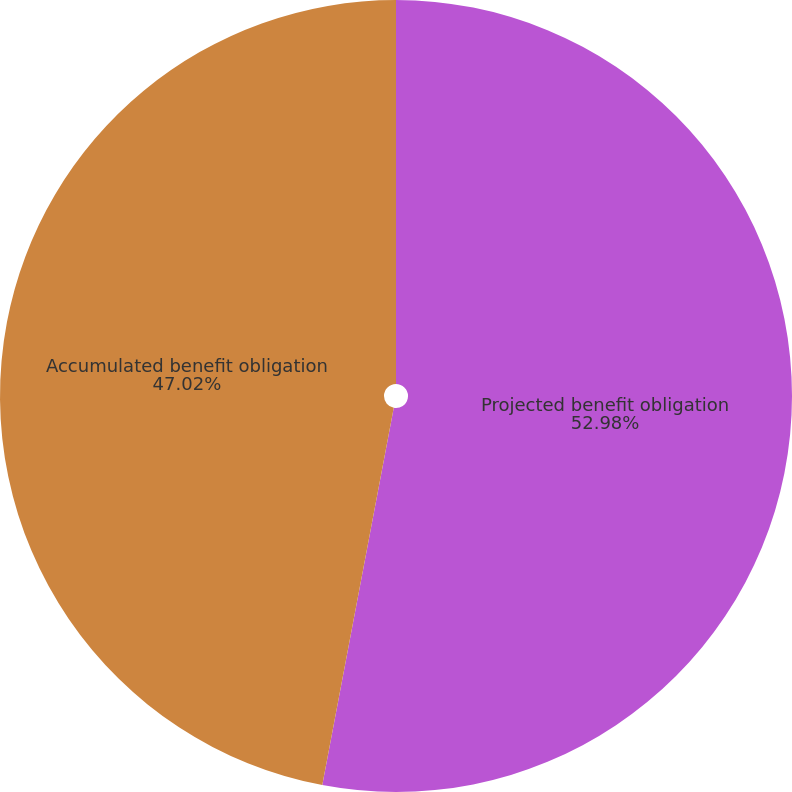Convert chart. <chart><loc_0><loc_0><loc_500><loc_500><pie_chart><fcel>Projected benefit obligation<fcel>Accumulated benefit obligation<nl><fcel>52.98%<fcel>47.02%<nl></chart> 